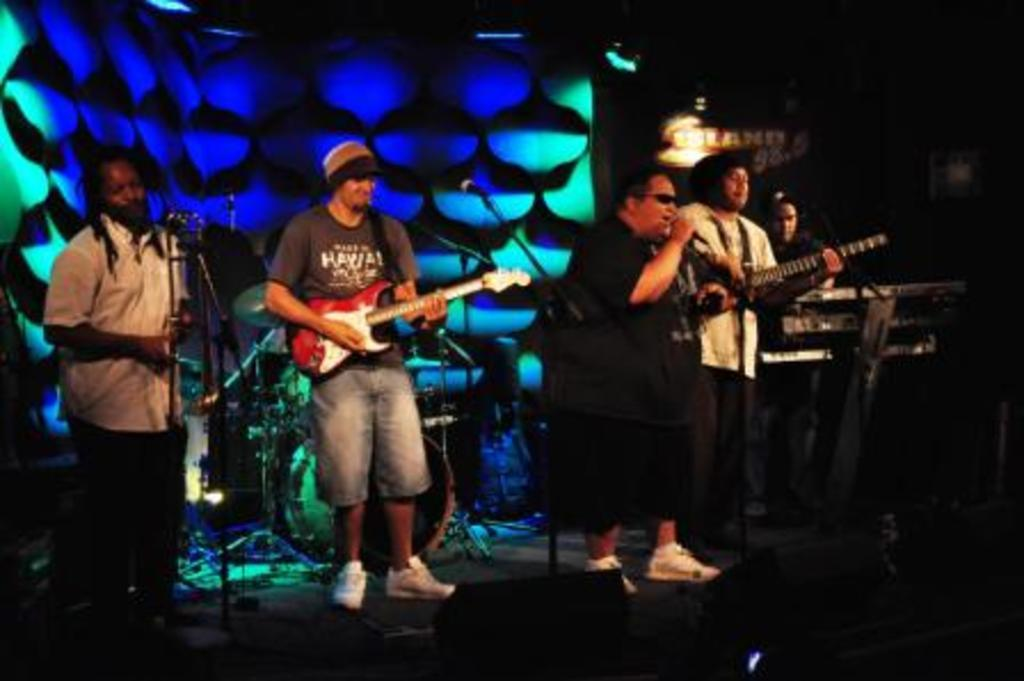How many people are in the image? There is a group of persons in the image. What are the persons in the image doing? The persons are playing musical instruments. Where is the scene taking place? The setting is on a stage. What type of pancake can be seen on the stage in the image? There is no pancake present in the image; the persons are playing musical instruments on a stage. 